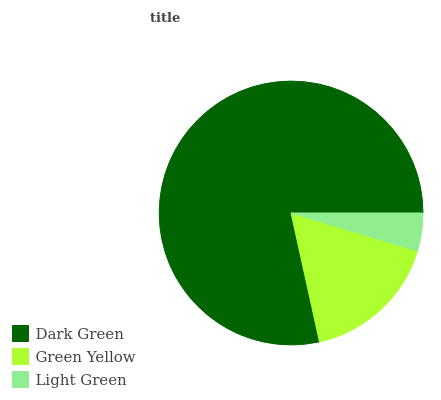Is Light Green the minimum?
Answer yes or no. Yes. Is Dark Green the maximum?
Answer yes or no. Yes. Is Green Yellow the minimum?
Answer yes or no. No. Is Green Yellow the maximum?
Answer yes or no. No. Is Dark Green greater than Green Yellow?
Answer yes or no. Yes. Is Green Yellow less than Dark Green?
Answer yes or no. Yes. Is Green Yellow greater than Dark Green?
Answer yes or no. No. Is Dark Green less than Green Yellow?
Answer yes or no. No. Is Green Yellow the high median?
Answer yes or no. Yes. Is Green Yellow the low median?
Answer yes or no. Yes. Is Light Green the high median?
Answer yes or no. No. Is Light Green the low median?
Answer yes or no. No. 